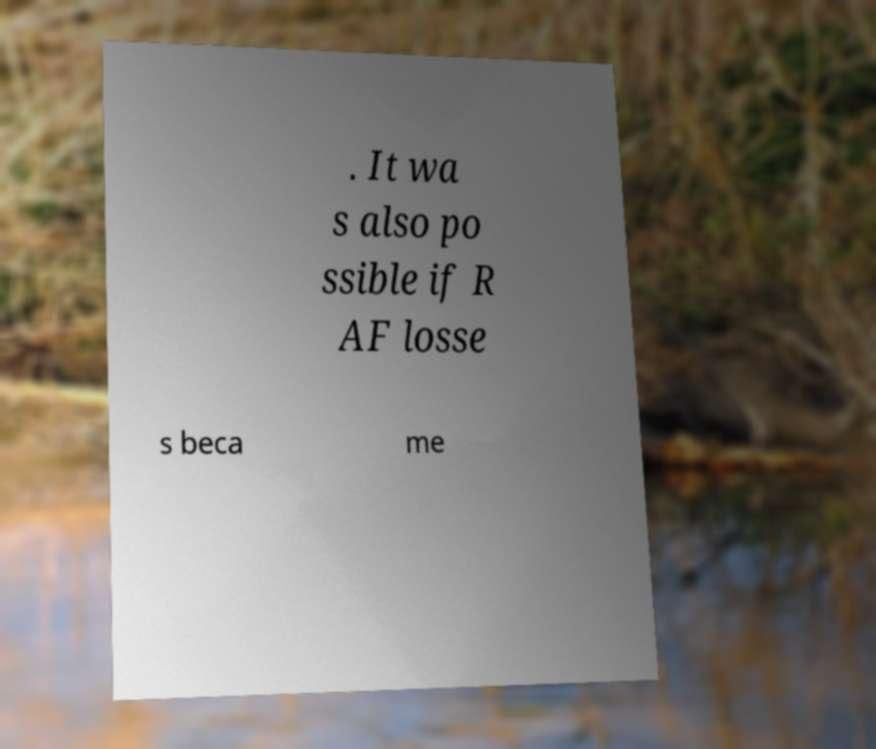Can you accurately transcribe the text from the provided image for me? . It wa s also po ssible if R AF losse s beca me 